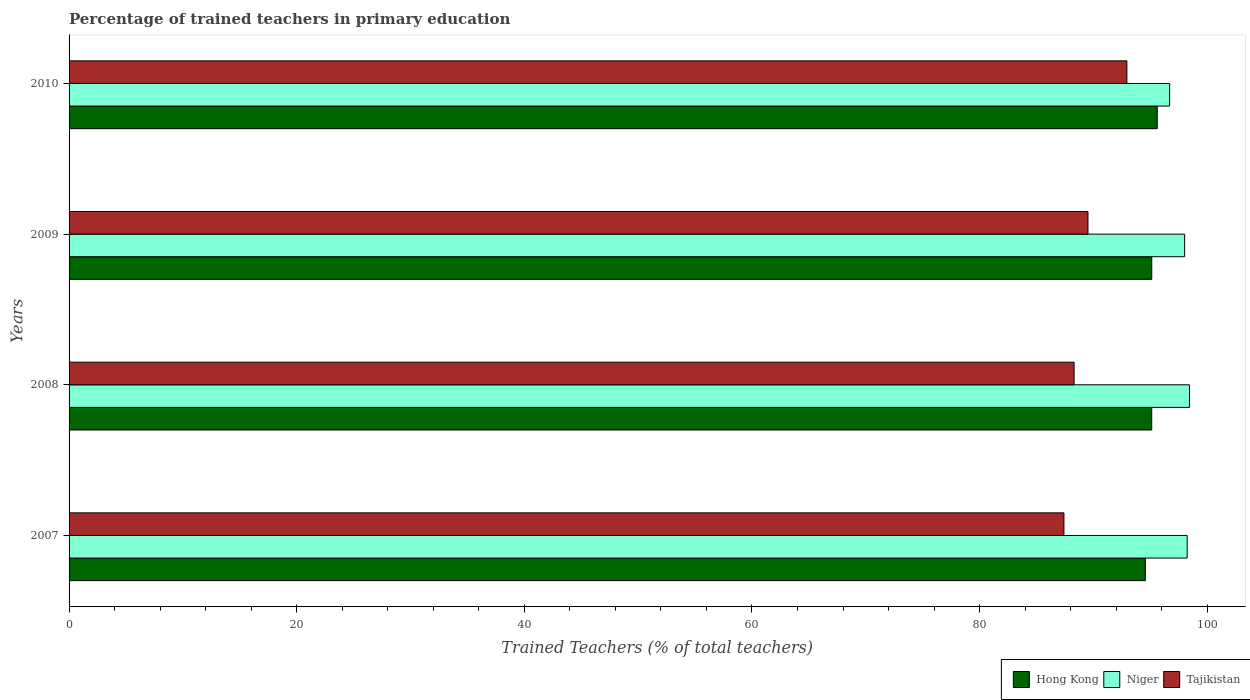How many groups of bars are there?
Provide a short and direct response. 4. How many bars are there on the 2nd tick from the top?
Ensure brevity in your answer.  3. What is the label of the 3rd group of bars from the top?
Offer a terse response. 2008. In how many cases, is the number of bars for a given year not equal to the number of legend labels?
Give a very brief answer. 0. What is the percentage of trained teachers in Hong Kong in 2009?
Offer a terse response. 95.12. Across all years, what is the maximum percentage of trained teachers in Niger?
Your response must be concise. 98.44. Across all years, what is the minimum percentage of trained teachers in Niger?
Provide a succinct answer. 96.69. In which year was the percentage of trained teachers in Tajikistan minimum?
Your answer should be compact. 2007. What is the total percentage of trained teachers in Hong Kong in the graph?
Ensure brevity in your answer.  380.41. What is the difference between the percentage of trained teachers in Niger in 2008 and that in 2010?
Offer a very short reply. 1.74. What is the difference between the percentage of trained teachers in Hong Kong in 2008 and the percentage of trained teachers in Niger in 2007?
Your answer should be compact. -3.12. What is the average percentage of trained teachers in Niger per year?
Keep it short and to the point. 97.85. In the year 2009, what is the difference between the percentage of trained teachers in Niger and percentage of trained teachers in Tajikistan?
Ensure brevity in your answer.  8.49. What is the ratio of the percentage of trained teachers in Hong Kong in 2007 to that in 2008?
Offer a very short reply. 0.99. Is the difference between the percentage of trained teachers in Niger in 2007 and 2010 greater than the difference between the percentage of trained teachers in Tajikistan in 2007 and 2010?
Your answer should be compact. Yes. What is the difference between the highest and the second highest percentage of trained teachers in Hong Kong?
Your answer should be compact. 0.48. What is the difference between the highest and the lowest percentage of trained teachers in Tajikistan?
Provide a short and direct response. 5.53. In how many years, is the percentage of trained teachers in Hong Kong greater than the average percentage of trained teachers in Hong Kong taken over all years?
Make the answer very short. 3. What does the 3rd bar from the top in 2007 represents?
Keep it short and to the point. Hong Kong. What does the 3rd bar from the bottom in 2009 represents?
Give a very brief answer. Tajikistan. Is it the case that in every year, the sum of the percentage of trained teachers in Tajikistan and percentage of trained teachers in Niger is greater than the percentage of trained teachers in Hong Kong?
Make the answer very short. Yes. Does the graph contain grids?
Your response must be concise. No. Where does the legend appear in the graph?
Your answer should be compact. Bottom right. How many legend labels are there?
Your response must be concise. 3. What is the title of the graph?
Your answer should be compact. Percentage of trained teachers in primary education. What is the label or title of the X-axis?
Give a very brief answer. Trained Teachers (% of total teachers). What is the Trained Teachers (% of total teachers) of Hong Kong in 2007?
Your answer should be compact. 94.56. What is the Trained Teachers (% of total teachers) in Niger in 2007?
Your answer should be compact. 98.24. What is the Trained Teachers (% of total teachers) in Tajikistan in 2007?
Offer a very short reply. 87.41. What is the Trained Teachers (% of total teachers) in Hong Kong in 2008?
Keep it short and to the point. 95.12. What is the Trained Teachers (% of total teachers) in Niger in 2008?
Offer a very short reply. 98.44. What is the Trained Teachers (% of total teachers) in Tajikistan in 2008?
Give a very brief answer. 88.3. What is the Trained Teachers (% of total teachers) in Hong Kong in 2009?
Offer a very short reply. 95.12. What is the Trained Teachers (% of total teachers) of Niger in 2009?
Provide a succinct answer. 98.01. What is the Trained Teachers (% of total teachers) in Tajikistan in 2009?
Your response must be concise. 89.52. What is the Trained Teachers (% of total teachers) in Hong Kong in 2010?
Give a very brief answer. 95.61. What is the Trained Teachers (% of total teachers) in Niger in 2010?
Your answer should be compact. 96.69. What is the Trained Teachers (% of total teachers) of Tajikistan in 2010?
Give a very brief answer. 92.94. Across all years, what is the maximum Trained Teachers (% of total teachers) in Hong Kong?
Provide a succinct answer. 95.61. Across all years, what is the maximum Trained Teachers (% of total teachers) in Niger?
Offer a very short reply. 98.44. Across all years, what is the maximum Trained Teachers (% of total teachers) in Tajikistan?
Your response must be concise. 92.94. Across all years, what is the minimum Trained Teachers (% of total teachers) in Hong Kong?
Make the answer very short. 94.56. Across all years, what is the minimum Trained Teachers (% of total teachers) of Niger?
Give a very brief answer. 96.69. Across all years, what is the minimum Trained Teachers (% of total teachers) of Tajikistan?
Your response must be concise. 87.41. What is the total Trained Teachers (% of total teachers) of Hong Kong in the graph?
Your answer should be very brief. 380.41. What is the total Trained Teachers (% of total teachers) in Niger in the graph?
Provide a short and direct response. 391.38. What is the total Trained Teachers (% of total teachers) of Tajikistan in the graph?
Offer a terse response. 358.17. What is the difference between the Trained Teachers (% of total teachers) of Hong Kong in 2007 and that in 2008?
Provide a short and direct response. -0.56. What is the difference between the Trained Teachers (% of total teachers) of Niger in 2007 and that in 2008?
Keep it short and to the point. -0.2. What is the difference between the Trained Teachers (% of total teachers) in Tajikistan in 2007 and that in 2008?
Provide a short and direct response. -0.89. What is the difference between the Trained Teachers (% of total teachers) of Hong Kong in 2007 and that in 2009?
Provide a succinct answer. -0.56. What is the difference between the Trained Teachers (% of total teachers) in Niger in 2007 and that in 2009?
Ensure brevity in your answer.  0.22. What is the difference between the Trained Teachers (% of total teachers) in Tajikistan in 2007 and that in 2009?
Ensure brevity in your answer.  -2.11. What is the difference between the Trained Teachers (% of total teachers) in Hong Kong in 2007 and that in 2010?
Your response must be concise. -1.05. What is the difference between the Trained Teachers (% of total teachers) in Niger in 2007 and that in 2010?
Make the answer very short. 1.54. What is the difference between the Trained Teachers (% of total teachers) of Tajikistan in 2007 and that in 2010?
Make the answer very short. -5.53. What is the difference between the Trained Teachers (% of total teachers) in Hong Kong in 2008 and that in 2009?
Your answer should be very brief. -0. What is the difference between the Trained Teachers (% of total teachers) of Niger in 2008 and that in 2009?
Provide a short and direct response. 0.42. What is the difference between the Trained Teachers (% of total teachers) of Tajikistan in 2008 and that in 2009?
Your answer should be compact. -1.22. What is the difference between the Trained Teachers (% of total teachers) of Hong Kong in 2008 and that in 2010?
Make the answer very short. -0.49. What is the difference between the Trained Teachers (% of total teachers) of Niger in 2008 and that in 2010?
Offer a terse response. 1.74. What is the difference between the Trained Teachers (% of total teachers) in Tajikistan in 2008 and that in 2010?
Provide a succinct answer. -4.64. What is the difference between the Trained Teachers (% of total teachers) in Hong Kong in 2009 and that in 2010?
Your answer should be compact. -0.48. What is the difference between the Trained Teachers (% of total teachers) of Niger in 2009 and that in 2010?
Your response must be concise. 1.32. What is the difference between the Trained Teachers (% of total teachers) of Tajikistan in 2009 and that in 2010?
Provide a succinct answer. -3.42. What is the difference between the Trained Teachers (% of total teachers) in Hong Kong in 2007 and the Trained Teachers (% of total teachers) in Niger in 2008?
Give a very brief answer. -3.88. What is the difference between the Trained Teachers (% of total teachers) of Hong Kong in 2007 and the Trained Teachers (% of total teachers) of Tajikistan in 2008?
Provide a succinct answer. 6.26. What is the difference between the Trained Teachers (% of total teachers) in Niger in 2007 and the Trained Teachers (% of total teachers) in Tajikistan in 2008?
Provide a succinct answer. 9.94. What is the difference between the Trained Teachers (% of total teachers) of Hong Kong in 2007 and the Trained Teachers (% of total teachers) of Niger in 2009?
Offer a terse response. -3.45. What is the difference between the Trained Teachers (% of total teachers) in Hong Kong in 2007 and the Trained Teachers (% of total teachers) in Tajikistan in 2009?
Your response must be concise. 5.04. What is the difference between the Trained Teachers (% of total teachers) of Niger in 2007 and the Trained Teachers (% of total teachers) of Tajikistan in 2009?
Offer a terse response. 8.72. What is the difference between the Trained Teachers (% of total teachers) of Hong Kong in 2007 and the Trained Teachers (% of total teachers) of Niger in 2010?
Your answer should be compact. -2.13. What is the difference between the Trained Teachers (% of total teachers) in Hong Kong in 2007 and the Trained Teachers (% of total teachers) in Tajikistan in 2010?
Give a very brief answer. 1.62. What is the difference between the Trained Teachers (% of total teachers) in Niger in 2007 and the Trained Teachers (% of total teachers) in Tajikistan in 2010?
Offer a terse response. 5.3. What is the difference between the Trained Teachers (% of total teachers) in Hong Kong in 2008 and the Trained Teachers (% of total teachers) in Niger in 2009?
Your answer should be very brief. -2.89. What is the difference between the Trained Teachers (% of total teachers) of Hong Kong in 2008 and the Trained Teachers (% of total teachers) of Tajikistan in 2009?
Provide a succinct answer. 5.6. What is the difference between the Trained Teachers (% of total teachers) in Niger in 2008 and the Trained Teachers (% of total teachers) in Tajikistan in 2009?
Ensure brevity in your answer.  8.92. What is the difference between the Trained Teachers (% of total teachers) in Hong Kong in 2008 and the Trained Teachers (% of total teachers) in Niger in 2010?
Provide a short and direct response. -1.57. What is the difference between the Trained Teachers (% of total teachers) in Hong Kong in 2008 and the Trained Teachers (% of total teachers) in Tajikistan in 2010?
Provide a succinct answer. 2.18. What is the difference between the Trained Teachers (% of total teachers) of Niger in 2008 and the Trained Teachers (% of total teachers) of Tajikistan in 2010?
Your response must be concise. 5.5. What is the difference between the Trained Teachers (% of total teachers) in Hong Kong in 2009 and the Trained Teachers (% of total teachers) in Niger in 2010?
Make the answer very short. -1.57. What is the difference between the Trained Teachers (% of total teachers) of Hong Kong in 2009 and the Trained Teachers (% of total teachers) of Tajikistan in 2010?
Give a very brief answer. 2.19. What is the difference between the Trained Teachers (% of total teachers) in Niger in 2009 and the Trained Teachers (% of total teachers) in Tajikistan in 2010?
Offer a very short reply. 5.08. What is the average Trained Teachers (% of total teachers) of Hong Kong per year?
Make the answer very short. 95.1. What is the average Trained Teachers (% of total teachers) of Niger per year?
Your response must be concise. 97.85. What is the average Trained Teachers (% of total teachers) in Tajikistan per year?
Provide a succinct answer. 89.54. In the year 2007, what is the difference between the Trained Teachers (% of total teachers) in Hong Kong and Trained Teachers (% of total teachers) in Niger?
Your answer should be very brief. -3.68. In the year 2007, what is the difference between the Trained Teachers (% of total teachers) of Hong Kong and Trained Teachers (% of total teachers) of Tajikistan?
Provide a succinct answer. 7.15. In the year 2007, what is the difference between the Trained Teachers (% of total teachers) of Niger and Trained Teachers (% of total teachers) of Tajikistan?
Offer a terse response. 10.83. In the year 2008, what is the difference between the Trained Teachers (% of total teachers) of Hong Kong and Trained Teachers (% of total teachers) of Niger?
Offer a terse response. -3.32. In the year 2008, what is the difference between the Trained Teachers (% of total teachers) in Hong Kong and Trained Teachers (% of total teachers) in Tajikistan?
Your answer should be very brief. 6.82. In the year 2008, what is the difference between the Trained Teachers (% of total teachers) in Niger and Trained Teachers (% of total teachers) in Tajikistan?
Provide a short and direct response. 10.14. In the year 2009, what is the difference between the Trained Teachers (% of total teachers) in Hong Kong and Trained Teachers (% of total teachers) in Niger?
Keep it short and to the point. -2.89. In the year 2009, what is the difference between the Trained Teachers (% of total teachers) in Hong Kong and Trained Teachers (% of total teachers) in Tajikistan?
Offer a very short reply. 5.6. In the year 2009, what is the difference between the Trained Teachers (% of total teachers) of Niger and Trained Teachers (% of total teachers) of Tajikistan?
Provide a succinct answer. 8.49. In the year 2010, what is the difference between the Trained Teachers (% of total teachers) of Hong Kong and Trained Teachers (% of total teachers) of Niger?
Ensure brevity in your answer.  -1.09. In the year 2010, what is the difference between the Trained Teachers (% of total teachers) in Hong Kong and Trained Teachers (% of total teachers) in Tajikistan?
Your response must be concise. 2.67. In the year 2010, what is the difference between the Trained Teachers (% of total teachers) in Niger and Trained Teachers (% of total teachers) in Tajikistan?
Make the answer very short. 3.76. What is the ratio of the Trained Teachers (% of total teachers) in Hong Kong in 2007 to that in 2008?
Offer a terse response. 0.99. What is the ratio of the Trained Teachers (% of total teachers) in Hong Kong in 2007 to that in 2009?
Keep it short and to the point. 0.99. What is the ratio of the Trained Teachers (% of total teachers) in Niger in 2007 to that in 2009?
Provide a succinct answer. 1. What is the ratio of the Trained Teachers (% of total teachers) in Tajikistan in 2007 to that in 2009?
Ensure brevity in your answer.  0.98. What is the ratio of the Trained Teachers (% of total teachers) of Niger in 2007 to that in 2010?
Your response must be concise. 1.02. What is the ratio of the Trained Teachers (% of total teachers) of Tajikistan in 2007 to that in 2010?
Offer a terse response. 0.94. What is the ratio of the Trained Teachers (% of total teachers) in Niger in 2008 to that in 2009?
Your answer should be very brief. 1. What is the ratio of the Trained Teachers (% of total teachers) of Tajikistan in 2008 to that in 2009?
Your answer should be compact. 0.99. What is the ratio of the Trained Teachers (% of total teachers) of Tajikistan in 2008 to that in 2010?
Provide a succinct answer. 0.95. What is the ratio of the Trained Teachers (% of total teachers) of Hong Kong in 2009 to that in 2010?
Your response must be concise. 0.99. What is the ratio of the Trained Teachers (% of total teachers) of Niger in 2009 to that in 2010?
Ensure brevity in your answer.  1.01. What is the ratio of the Trained Teachers (% of total teachers) of Tajikistan in 2009 to that in 2010?
Make the answer very short. 0.96. What is the difference between the highest and the second highest Trained Teachers (% of total teachers) in Hong Kong?
Keep it short and to the point. 0.48. What is the difference between the highest and the second highest Trained Teachers (% of total teachers) of Niger?
Your answer should be compact. 0.2. What is the difference between the highest and the second highest Trained Teachers (% of total teachers) of Tajikistan?
Offer a terse response. 3.42. What is the difference between the highest and the lowest Trained Teachers (% of total teachers) of Hong Kong?
Your answer should be compact. 1.05. What is the difference between the highest and the lowest Trained Teachers (% of total teachers) in Niger?
Make the answer very short. 1.74. What is the difference between the highest and the lowest Trained Teachers (% of total teachers) in Tajikistan?
Give a very brief answer. 5.53. 